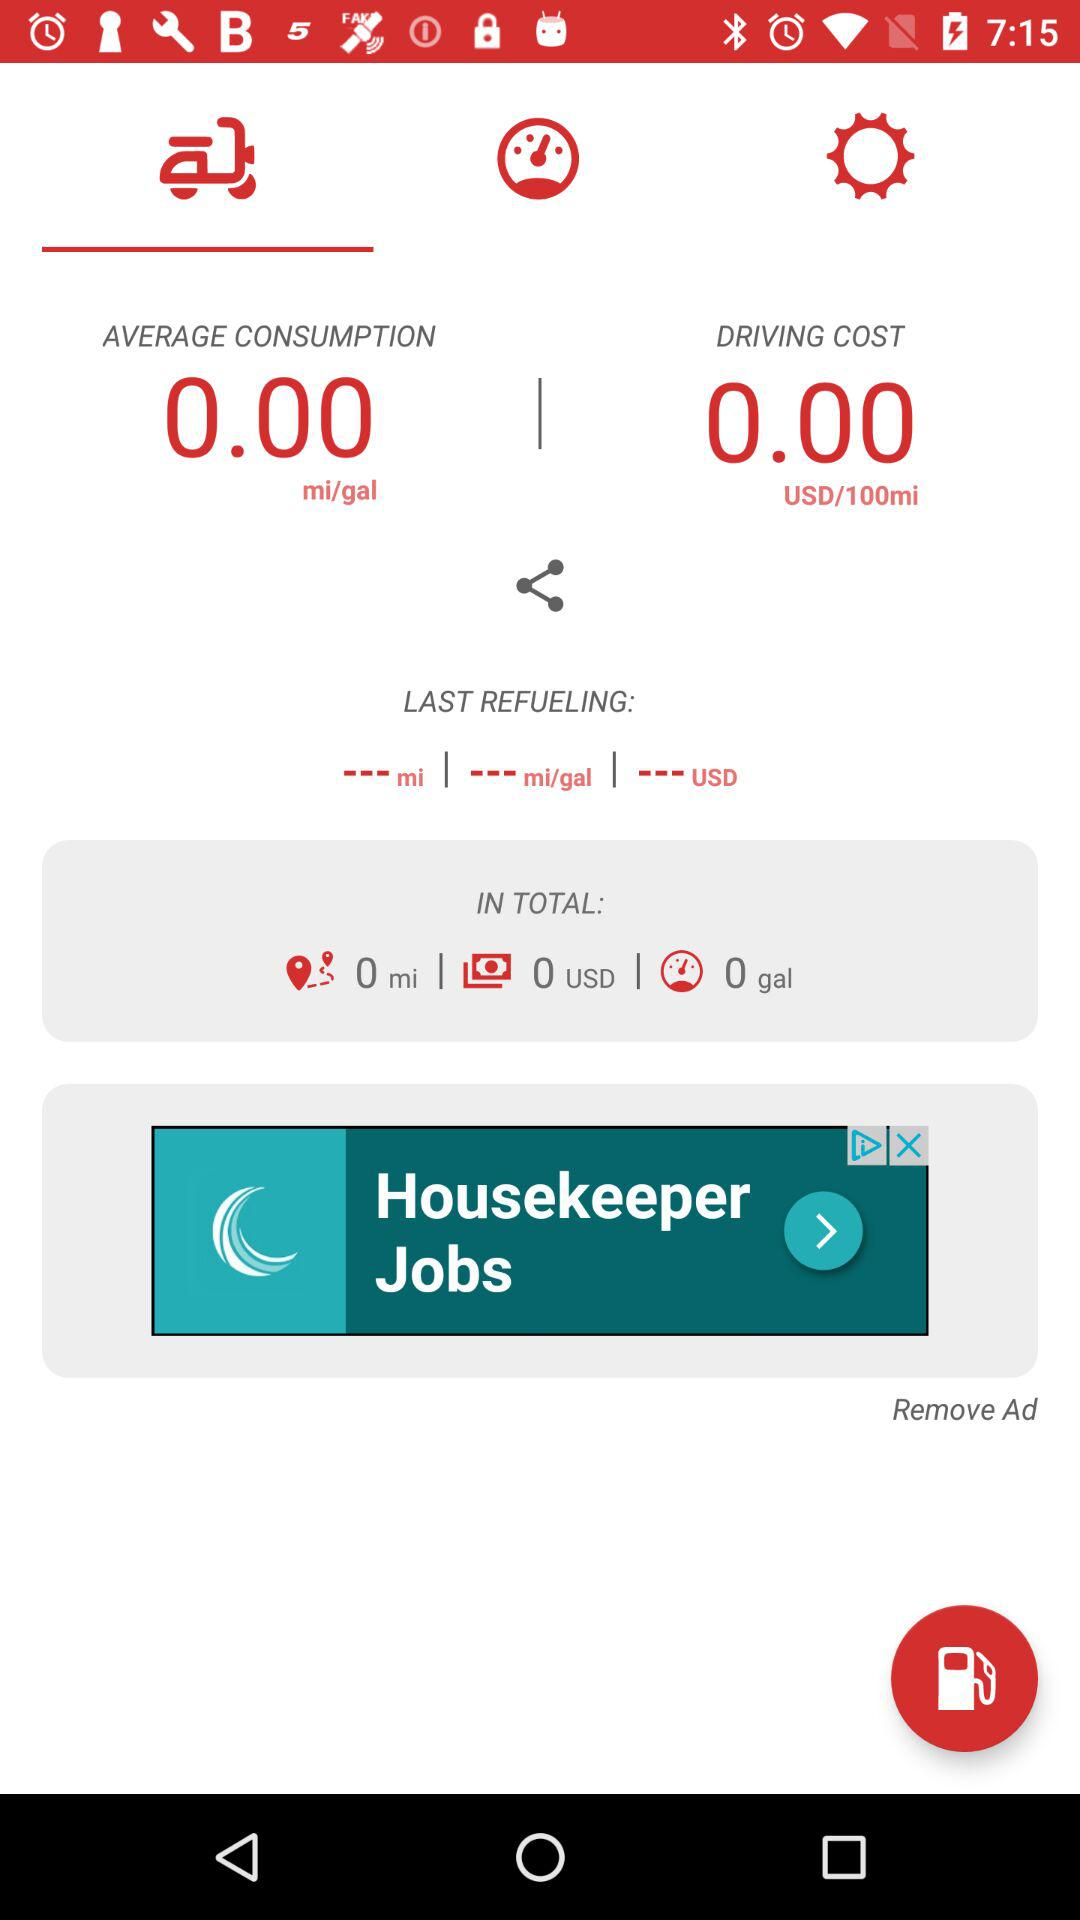Which unit is average consumption measured in? The average consumption is measured in miles per gallon (mi/gal). 